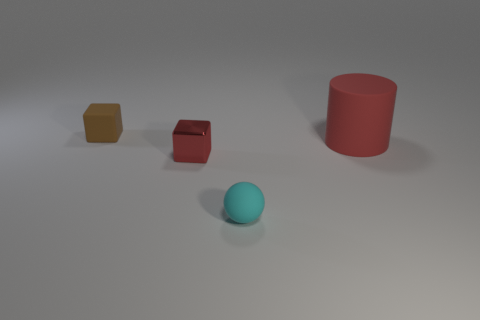Is the rubber cylinder the same color as the small metal object?
Your answer should be compact. Yes. Are there fewer small red objects than tiny cubes?
Your response must be concise. Yes. How many other things are made of the same material as the cyan ball?
Offer a very short reply. 2. Is the red thing that is to the left of the red cylinder made of the same material as the thing to the right of the cyan ball?
Provide a succinct answer. No. Is the number of matte objects behind the small red thing less than the number of small things?
Your answer should be very brief. Yes. Are there any other things that are the same shape as the small cyan object?
Provide a short and direct response. No. What color is the other object that is the same shape as the tiny metal thing?
Ensure brevity in your answer.  Brown. Do the thing that is left of the red metal block and the cyan matte sphere have the same size?
Your response must be concise. Yes. How big is the matte sphere on the right side of the tiny matte thing that is behind the ball?
Make the answer very short. Small. Are the small red block and the thing that is on the right side of the small matte sphere made of the same material?
Offer a terse response. No. 